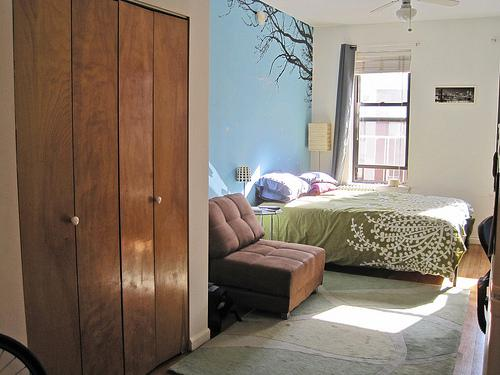Question: where are the pillows?
Choices:
A. On the sofa.
B. On Bed.
C. On the floor.
D. On the shelves.
Answer with the letter. Answer: B Question: what type of floor is under the rug?
Choices:
A. Tile.
B. Wood.
C. Carpet.
D. Concrete.
Answer with the letter. Answer: B Question: what color is the chair in the photo?
Choices:
A. Brown.
B. Blue.
C. Yellow.
D. Green.
Answer with the letter. Answer: A Question: what color is the wall with the tree on it?
Choices:
A. White.
B. Black.
C. Blue.
D. Grey.
Answer with the letter. Answer: C Question: how many pillows are on the bed?
Choices:
A. One.
B. Four.
C. Seven.
D. Ten.
Answer with the letter. Answer: B 